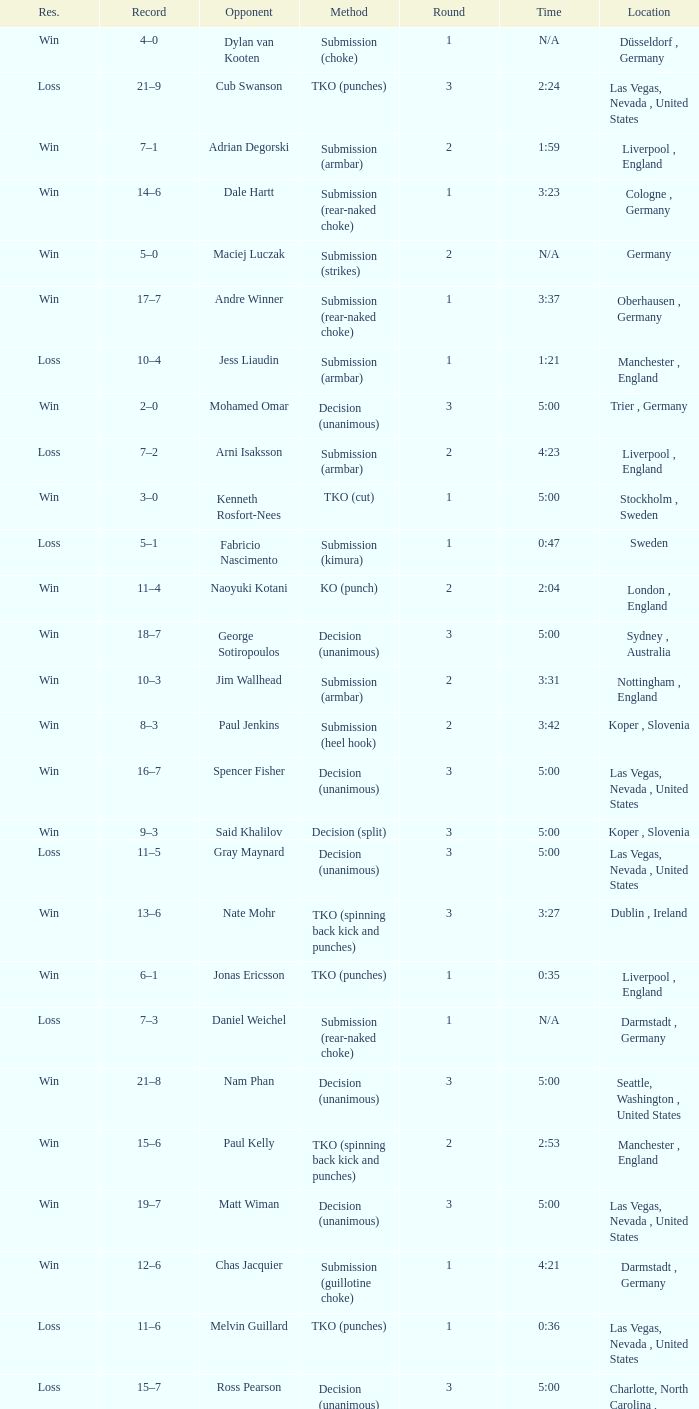Would you be able to parse every entry in this table? {'header': ['Res.', 'Record', 'Opponent', 'Method', 'Round', 'Time', 'Location'], 'rows': [['Win', '4–0', 'Dylan van Kooten', 'Submission (choke)', '1', 'N/A', 'Düsseldorf , Germany'], ['Loss', '21–9', 'Cub Swanson', 'TKO (punches)', '3', '2:24', 'Las Vegas, Nevada , United States'], ['Win', '7–1', 'Adrian Degorski', 'Submission (armbar)', '2', '1:59', 'Liverpool , England'], ['Win', '14–6', 'Dale Hartt', 'Submission (rear-naked choke)', '1', '3:23', 'Cologne , Germany'], ['Win', '5–0', 'Maciej Luczak', 'Submission (strikes)', '2', 'N/A', 'Germany'], ['Win', '17–7', 'Andre Winner', 'Submission (rear-naked choke)', '1', '3:37', 'Oberhausen , Germany'], ['Loss', '10–4', 'Jess Liaudin', 'Submission (armbar)', '1', '1:21', 'Manchester , England'], ['Win', '2–0', 'Mohamed Omar', 'Decision (unanimous)', '3', '5:00', 'Trier , Germany'], ['Loss', '7–2', 'Arni Isaksson', 'Submission (armbar)', '2', '4:23', 'Liverpool , England'], ['Win', '3–0', 'Kenneth Rosfort-Nees', 'TKO (cut)', '1', '5:00', 'Stockholm , Sweden'], ['Loss', '5–1', 'Fabricio Nascimento', 'Submission (kimura)', '1', '0:47', 'Sweden'], ['Win', '11–4', 'Naoyuki Kotani', 'KO (punch)', '2', '2:04', 'London , England'], ['Win', '18–7', 'George Sotiropoulos', 'Decision (unanimous)', '3', '5:00', 'Sydney , Australia'], ['Win', '10–3', 'Jim Wallhead', 'Submission (armbar)', '2', '3:31', 'Nottingham , England'], ['Win', '8–3', 'Paul Jenkins', 'Submission (heel hook)', '2', '3:42', 'Koper , Slovenia'], ['Win', '16–7', 'Spencer Fisher', 'Decision (unanimous)', '3', '5:00', 'Las Vegas, Nevada , United States'], ['Win', '9–3', 'Said Khalilov', 'Decision (split)', '3', '5:00', 'Koper , Slovenia'], ['Loss', '11–5', 'Gray Maynard', 'Decision (unanimous)', '3', '5:00', 'Las Vegas, Nevada , United States'], ['Win', '13–6', 'Nate Mohr', 'TKO (spinning back kick and punches)', '3', '3:27', 'Dublin , Ireland'], ['Win', '6–1', 'Jonas Ericsson', 'TKO (punches)', '1', '0:35', 'Liverpool , England'], ['Loss', '7–3', 'Daniel Weichel', 'Submission (rear-naked choke)', '1', 'N/A', 'Darmstadt , Germany'], ['Win', '21–8', 'Nam Phan', 'Decision (unanimous)', '3', '5:00', 'Seattle, Washington , United States'], ['Win', '15–6', 'Paul Kelly', 'TKO (spinning back kick and punches)', '2', '2:53', 'Manchester , England'], ['Win', '19–7', 'Matt Wiman', 'Decision (unanimous)', '3', '5:00', 'Las Vegas, Nevada , United States'], ['Win', '12–6', 'Chas Jacquier', 'Submission (guillotine choke)', '1', '4:21', 'Darmstadt , Germany'], ['Loss', '11–6', 'Melvin Guillard', 'TKO (punches)', '1', '0:36', 'Las Vegas, Nevada , United States'], ['Loss', '15–7', 'Ross Pearson', 'Decision (unanimous)', '3', '5:00', 'Charlotte, North Carolina , United States'], ['Win', '1–0', 'Kordian Szukala', 'Submission (strikes)', '1', '0:17', 'Lübbecke , Germany'], ['Win', '20–8', 'Diego Nunes', 'Decision (unanimous)', '3', '5:00', 'Stockholm , Sweden'], ['Loss', '19–8', 'Donald Cerrone', 'Submission (rear-naked choke)', '1', '2:22', 'Las Vegas, Nevada , United States']]} What was the method of resolution for the fight against dale hartt? Submission (rear-naked choke). 